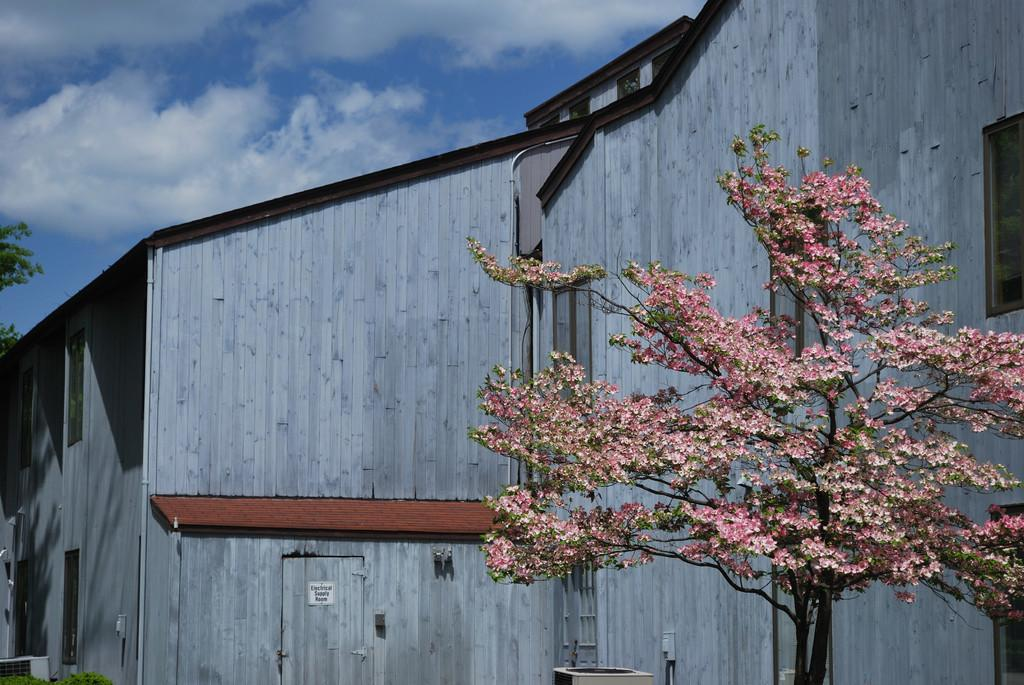What type of structure is visible in the image? There is a building in the image. What natural elements can be seen in the image? There are trees in the image. How would you describe the weather in the image? The sky is cloudy in the image. What is the purpose of the board in the image? There is a board in the image, but its purpose cannot be determined from the facts provided. What type of plant is present in the image? There is a plant in the image. Can you describe the objects in the image? There are objects in the image, but their specific nature cannot be determined from the facts provided. How many horses are visible in the image? There are no horses present in the image. Where are the frogs located in the image? There are no frogs present in the image. 